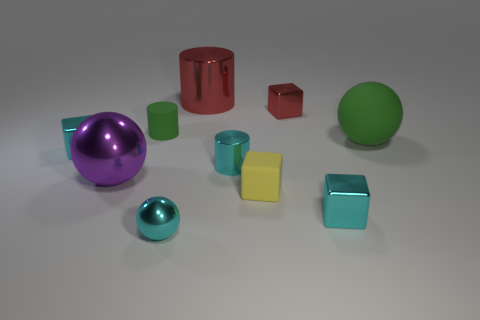There is a red cylinder that is to the right of the large shiny object that is in front of the metal cylinder behind the tiny green rubber object; what is its size?
Offer a very short reply. Large. Does the yellow matte block have the same size as the green rubber cylinder?
Offer a very short reply. Yes. How many objects are tiny cyan shiny cubes or tiny blue metallic cylinders?
Provide a succinct answer. 2. There is a shiny cylinder behind the ball that is to the right of the big shiny cylinder; how big is it?
Provide a succinct answer. Large. What size is the rubber cylinder?
Offer a terse response. Small. The thing that is both to the right of the large red object and behind the small green cylinder has what shape?
Keep it short and to the point. Cube. What color is the other big thing that is the same shape as the large green matte object?
Keep it short and to the point. Purple. What number of objects are either things to the left of the large red cylinder or cylinders behind the large green rubber sphere?
Your answer should be compact. 5. There is a tiny green object; what shape is it?
Your answer should be compact. Cylinder. There is a tiny object that is the same color as the large matte object; what is its shape?
Keep it short and to the point. Cylinder. 